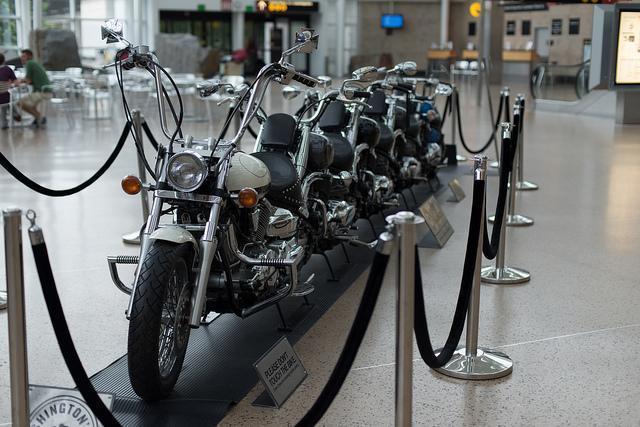How many motorcycles are in the photo?
Give a very brief answer. 4. 